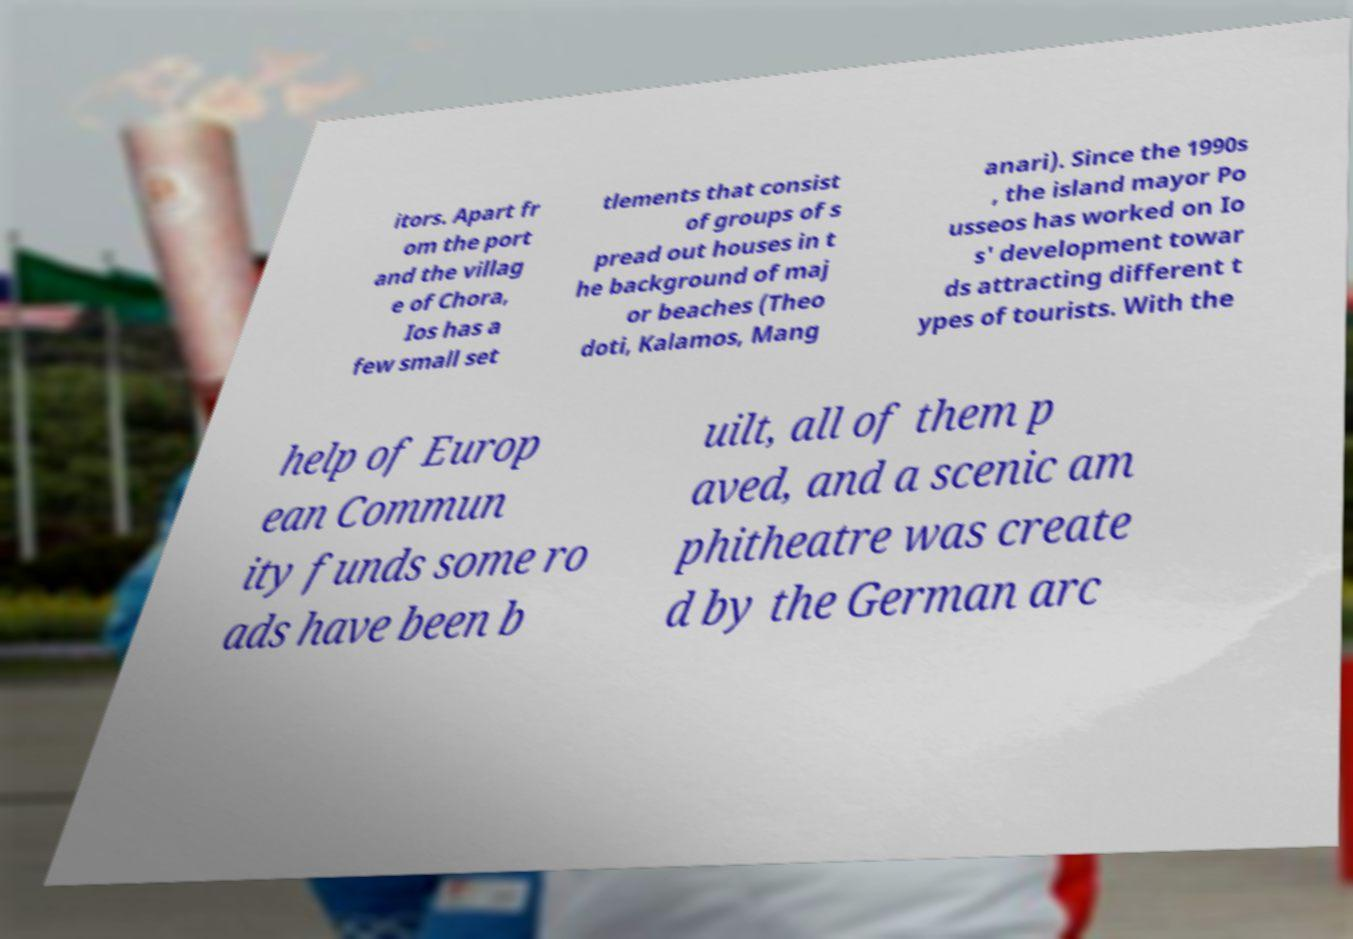Could you extract and type out the text from this image? itors. Apart fr om the port and the villag e of Chora, Ios has a few small set tlements that consist of groups of s pread out houses in t he background of maj or beaches (Theo doti, Kalamos, Mang anari). Since the 1990s , the island mayor Po usseos has worked on Io s' development towar ds attracting different t ypes of tourists. With the help of Europ ean Commun ity funds some ro ads have been b uilt, all of them p aved, and a scenic am phitheatre was create d by the German arc 